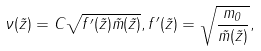<formula> <loc_0><loc_0><loc_500><loc_500>\nu ( \tilde { z } ) = C \sqrt { f ^ { \prime } ( \tilde { z } ) \tilde { m } ( \tilde { z } ) } , f ^ { \prime } ( \tilde { z } ) = \sqrt { \frac { m _ { 0 } } { \tilde { m } ( \tilde { z } ) } } ,</formula> 